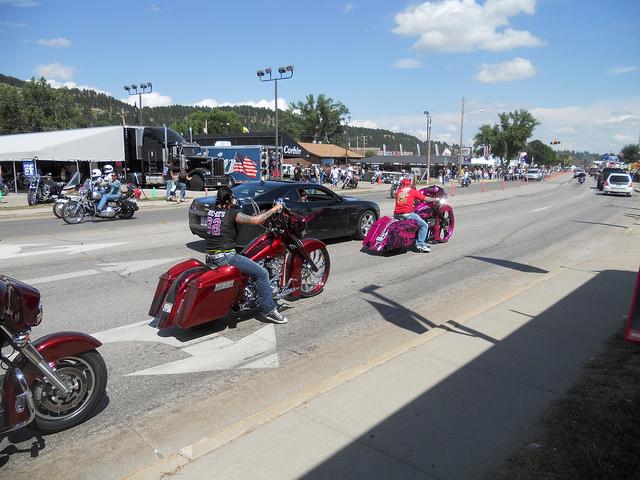Is this a race or a parade?
Short answer required. Parade. Is the street wet?
Quick response, please. No. What is this activity?
Be succinct. Motorcycle riding. Are there people on the motorcycle?
Give a very brief answer. Yes. How wide is the road?
Answer briefly. 4 lanes. Does it look like it might rain?
Write a very short answer. No. Does the red motorbike look new?
Be succinct. Yes. How many men are riding the motorcycle?
Answer briefly. 2. What is bigger, the bike or the car?
Give a very brief answer. Car. 